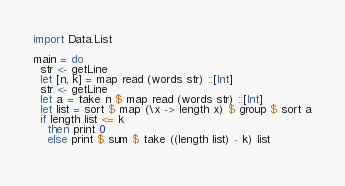Convert code to text. <code><loc_0><loc_0><loc_500><loc_500><_Haskell_>import Data.List

main = do
  str <- getLine
  let [n, k] = map read (words str) ::[Int]
  str <- getLine
  let a = take n $ map read (words str) ::[Int]
  let list = sort $ map (\x -> length x) $ group $ sort a
  if length list <= k
    then print 0
    else print $ sum $ take ((length list) - k) list
  </code> 